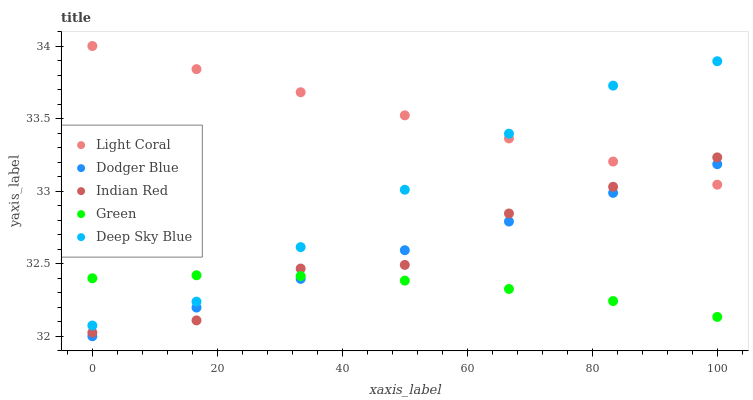Does Green have the minimum area under the curve?
Answer yes or no. Yes. Does Light Coral have the maximum area under the curve?
Answer yes or no. Yes. Does Dodger Blue have the minimum area under the curve?
Answer yes or no. No. Does Dodger Blue have the maximum area under the curve?
Answer yes or no. No. Is Dodger Blue the smoothest?
Answer yes or no. Yes. Is Indian Red the roughest?
Answer yes or no. Yes. Is Green the smoothest?
Answer yes or no. No. Is Green the roughest?
Answer yes or no. No. Does Dodger Blue have the lowest value?
Answer yes or no. Yes. Does Green have the lowest value?
Answer yes or no. No. Does Light Coral have the highest value?
Answer yes or no. Yes. Does Dodger Blue have the highest value?
Answer yes or no. No. Is Dodger Blue less than Deep Sky Blue?
Answer yes or no. Yes. Is Light Coral greater than Green?
Answer yes or no. Yes. Does Light Coral intersect Indian Red?
Answer yes or no. Yes. Is Light Coral less than Indian Red?
Answer yes or no. No. Is Light Coral greater than Indian Red?
Answer yes or no. No. Does Dodger Blue intersect Deep Sky Blue?
Answer yes or no. No. 